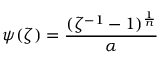<formula> <loc_0><loc_0><loc_500><loc_500>\psi ( \zeta ) = \frac { ( \zeta ^ { - 1 } - 1 ) ^ { \frac { 1 } { n } } } { \alpha }</formula> 